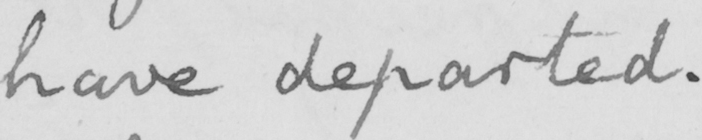What is written in this line of handwriting? have departed . 